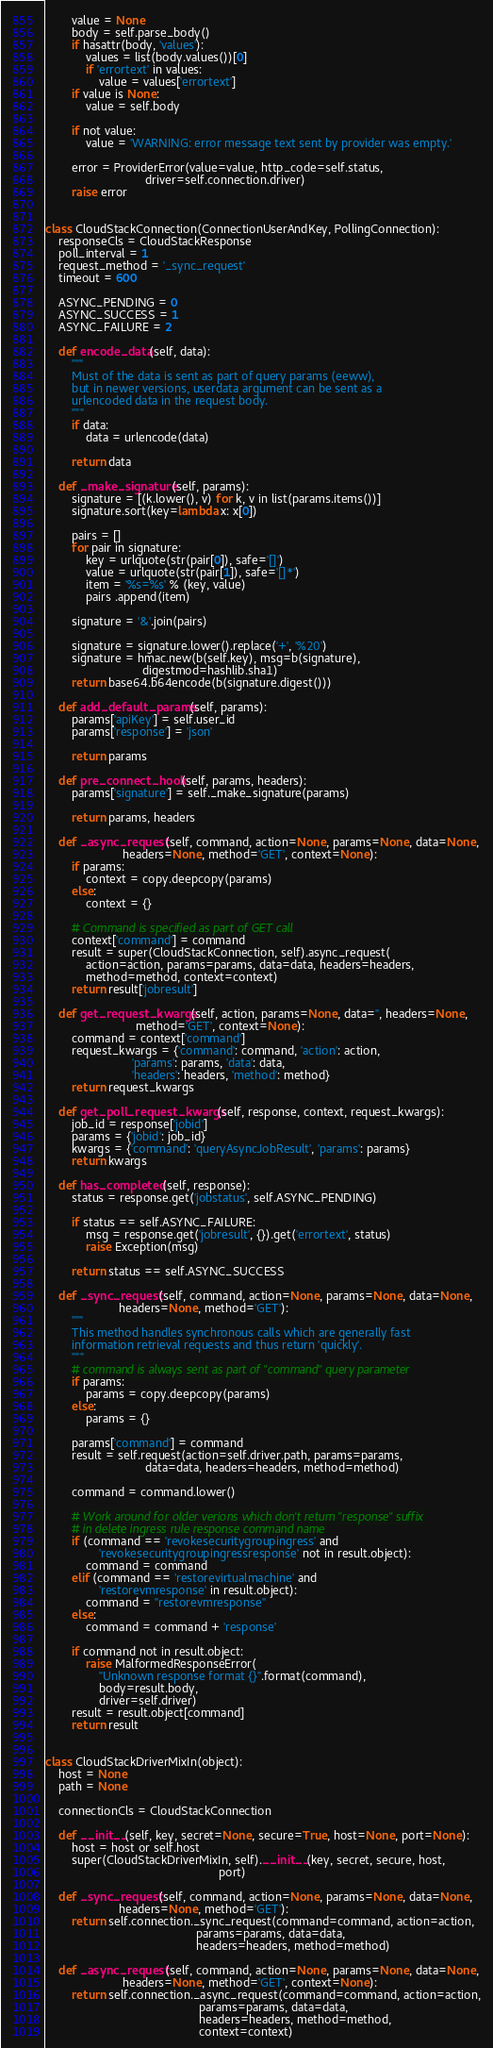Convert code to text. <code><loc_0><loc_0><loc_500><loc_500><_Python_>        value = None
        body = self.parse_body()
        if hasattr(body, 'values'):
            values = list(body.values())[0]
            if 'errortext' in values:
                value = values['errortext']
        if value is None:
            value = self.body

        if not value:
            value = 'WARNING: error message text sent by provider was empty.'

        error = ProviderError(value=value, http_code=self.status,
                              driver=self.connection.driver)
        raise error


class CloudStackConnection(ConnectionUserAndKey, PollingConnection):
    responseCls = CloudStackResponse
    poll_interval = 1
    request_method = '_sync_request'
    timeout = 600

    ASYNC_PENDING = 0
    ASYNC_SUCCESS = 1
    ASYNC_FAILURE = 2

    def encode_data(self, data):
        """
        Must of the data is sent as part of query params (eeww),
        but in newer versions, userdata argument can be sent as a
        urlencoded data in the request body.
        """
        if data:
            data = urlencode(data)

        return data

    def _make_signature(self, params):
        signature = [(k.lower(), v) for k, v in list(params.items())]
        signature.sort(key=lambda x: x[0])

        pairs = []
        for pair in signature:
            key = urlquote(str(pair[0]), safe='[]')
            value = urlquote(str(pair[1]), safe='[]*')
            item = '%s=%s' % (key, value)
            pairs .append(item)

        signature = '&'.join(pairs)

        signature = signature.lower().replace('+', '%20')
        signature = hmac.new(b(self.key), msg=b(signature),
                             digestmod=hashlib.sha1)
        return base64.b64encode(b(signature.digest()))

    def add_default_params(self, params):
        params['apiKey'] = self.user_id
        params['response'] = 'json'

        return params

    def pre_connect_hook(self, params, headers):
        params['signature'] = self._make_signature(params)

        return params, headers

    def _async_request(self, command, action=None, params=None, data=None,
                       headers=None, method='GET', context=None):
        if params:
            context = copy.deepcopy(params)
        else:
            context = {}

        # Command is specified as part of GET call
        context['command'] = command
        result = super(CloudStackConnection, self).async_request(
            action=action, params=params, data=data, headers=headers,
            method=method, context=context)
        return result['jobresult']

    def get_request_kwargs(self, action, params=None, data='', headers=None,
                           method='GET', context=None):
        command = context['command']
        request_kwargs = {'command': command, 'action': action,
                          'params': params, 'data': data,
                          'headers': headers, 'method': method}
        return request_kwargs

    def get_poll_request_kwargs(self, response, context, request_kwargs):
        job_id = response['jobid']
        params = {'jobid': job_id}
        kwargs = {'command': 'queryAsyncJobResult', 'params': params}
        return kwargs

    def has_completed(self, response):
        status = response.get('jobstatus', self.ASYNC_PENDING)

        if status == self.ASYNC_FAILURE:
            msg = response.get('jobresult', {}).get('errortext', status)
            raise Exception(msg)

        return status == self.ASYNC_SUCCESS

    def _sync_request(self, command, action=None, params=None, data=None,
                      headers=None, method='GET'):
        """
        This method handles synchronous calls which are generally fast
        information retrieval requests and thus return 'quickly'.
        """
        # command is always sent as part of "command" query parameter
        if params:
            params = copy.deepcopy(params)
        else:
            params = {}

        params['command'] = command
        result = self.request(action=self.driver.path, params=params,
                              data=data, headers=headers, method=method)

        command = command.lower()

        # Work around for older verions which don't return "response" suffix
        # in delete ingress rule response command name
        if (command == 'revokesecuritygroupingress' and
                'revokesecuritygroupingressresponse' not in result.object):
            command = command
        elif (command == 'restorevirtualmachine' and
                'restorevmresponse' in result.object):
            command = "restorevmresponse"
        else:
            command = command + 'response'

        if command not in result.object:
            raise MalformedResponseError(
                "Unknown response format {}".format(command),
                body=result.body,
                driver=self.driver)
        result = result.object[command]
        return result


class CloudStackDriverMixIn(object):
    host = None
    path = None

    connectionCls = CloudStackConnection

    def __init__(self, key, secret=None, secure=True, host=None, port=None):
        host = host or self.host
        super(CloudStackDriverMixIn, self).__init__(key, secret, secure, host,
                                                    port)

    def _sync_request(self, command, action=None, params=None, data=None,
                      headers=None, method='GET'):
        return self.connection._sync_request(command=command, action=action,
                                             params=params, data=data,
                                             headers=headers, method=method)

    def _async_request(self, command, action=None, params=None, data=None,
                       headers=None, method='GET', context=None):
        return self.connection._async_request(command=command, action=action,
                                              params=params, data=data,
                                              headers=headers, method=method,
                                              context=context)
</code> 